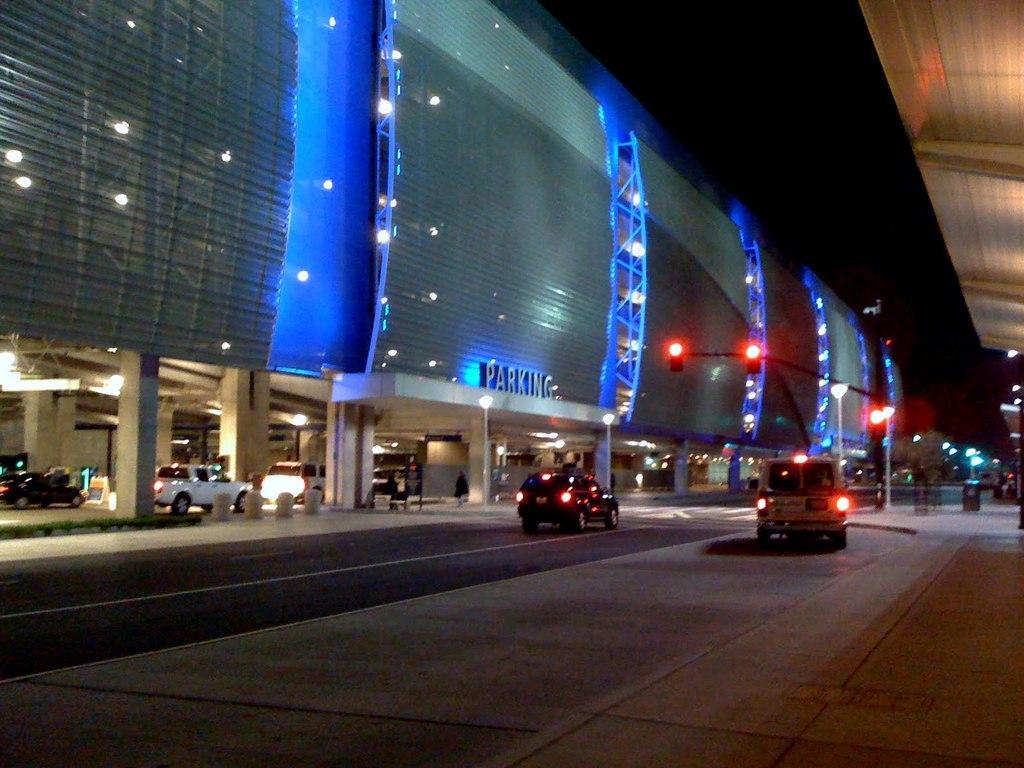Could you give a brief overview of what you see in this image? This is an image clicked in the dark. On the left side there is a road and there are two cars on this road. In the Background there is a building. Under the building there are some pillars and few cars on the ground. On both sides of the road there are some light poles. 